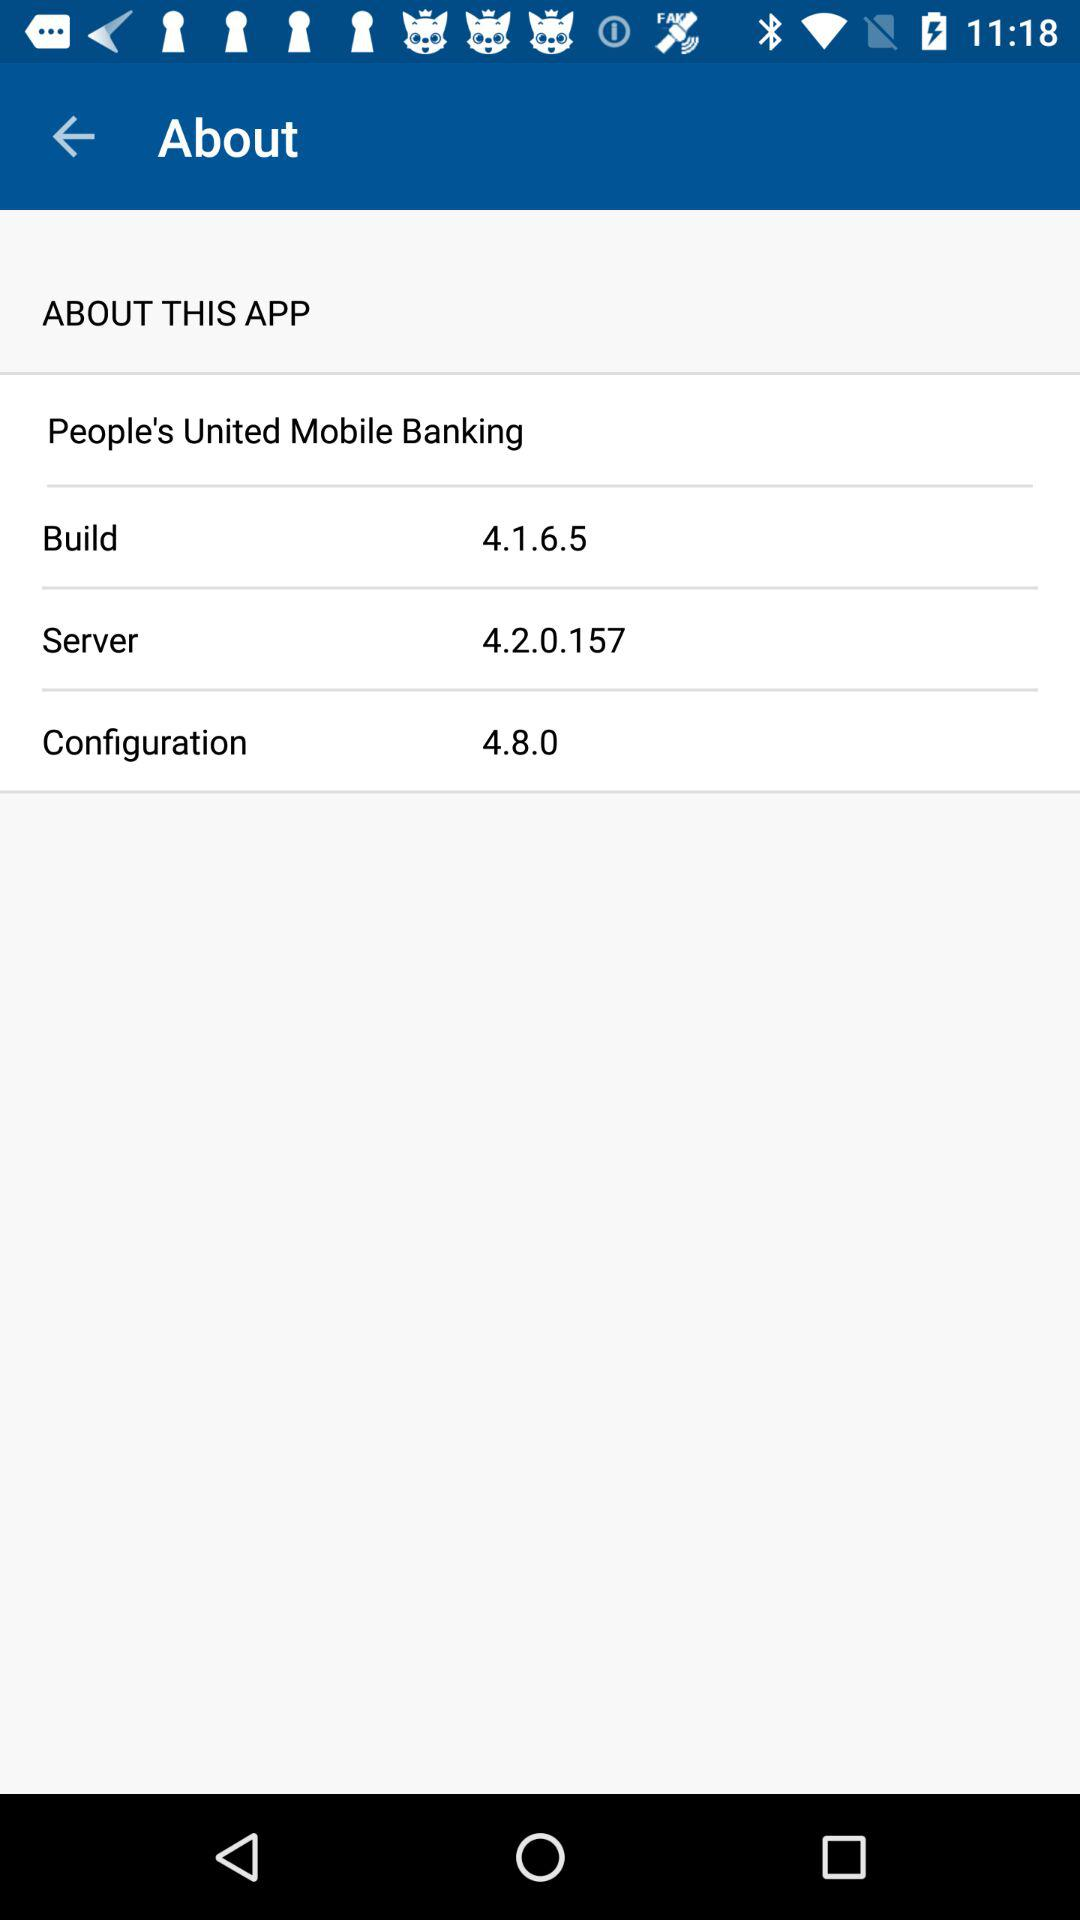What is the configuration? The configuration is 4.8.0. 